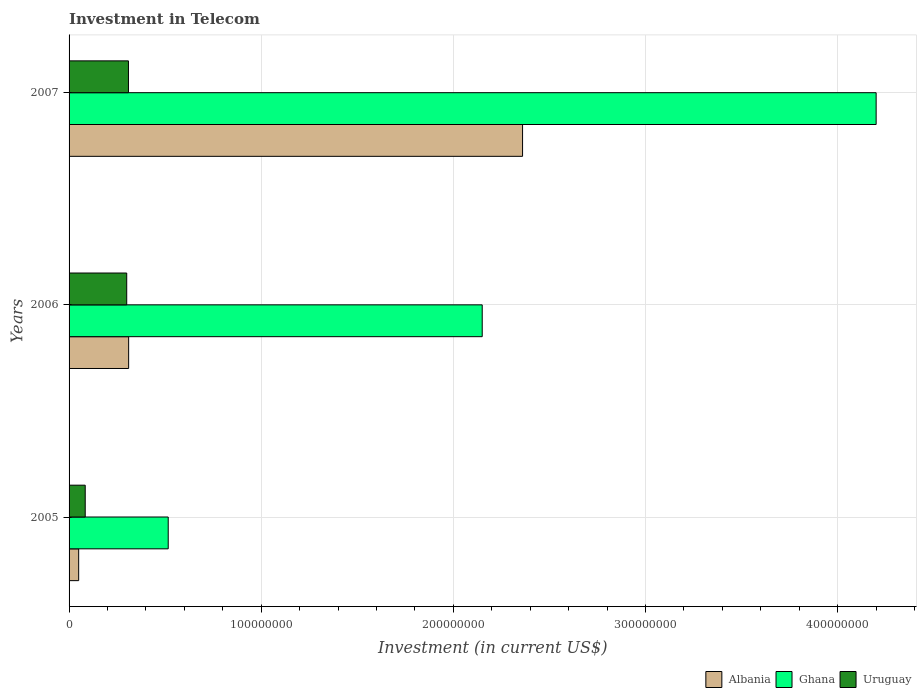Are the number of bars per tick equal to the number of legend labels?
Provide a succinct answer. Yes. In how many cases, is the number of bars for a given year not equal to the number of legend labels?
Provide a short and direct response. 0. What is the amount invested in telecom in Uruguay in 2005?
Provide a short and direct response. 8.40e+06. Across all years, what is the maximum amount invested in telecom in Albania?
Your answer should be very brief. 2.36e+08. Across all years, what is the minimum amount invested in telecom in Albania?
Your answer should be compact. 5.00e+06. What is the total amount invested in telecom in Albania in the graph?
Give a very brief answer. 2.72e+08. What is the difference between the amount invested in telecom in Ghana in 2006 and that in 2007?
Your answer should be compact. -2.05e+08. What is the difference between the amount invested in telecom in Albania in 2006 and the amount invested in telecom in Uruguay in 2005?
Provide a short and direct response. 2.26e+07. What is the average amount invested in telecom in Ghana per year?
Give a very brief answer. 2.29e+08. In the year 2006, what is the difference between the amount invested in telecom in Albania and amount invested in telecom in Ghana?
Make the answer very short. -1.84e+08. In how many years, is the amount invested in telecom in Ghana greater than 80000000 US$?
Your answer should be compact. 2. What is the ratio of the amount invested in telecom in Uruguay in 2006 to that in 2007?
Ensure brevity in your answer.  0.97. Is the amount invested in telecom in Albania in 2005 less than that in 2007?
Ensure brevity in your answer.  Yes. Is the difference between the amount invested in telecom in Albania in 2005 and 2006 greater than the difference between the amount invested in telecom in Ghana in 2005 and 2006?
Provide a succinct answer. Yes. What is the difference between the highest and the second highest amount invested in telecom in Ghana?
Give a very brief answer. 2.05e+08. What is the difference between the highest and the lowest amount invested in telecom in Ghana?
Your answer should be very brief. 3.68e+08. Is the sum of the amount invested in telecom in Ghana in 2006 and 2007 greater than the maximum amount invested in telecom in Albania across all years?
Offer a very short reply. Yes. What is the difference between two consecutive major ticks on the X-axis?
Give a very brief answer. 1.00e+08. Does the graph contain grids?
Your answer should be compact. Yes. Where does the legend appear in the graph?
Provide a succinct answer. Bottom right. How are the legend labels stacked?
Your answer should be compact. Horizontal. What is the title of the graph?
Provide a succinct answer. Investment in Telecom. Does "Papua New Guinea" appear as one of the legend labels in the graph?
Your answer should be compact. No. What is the label or title of the X-axis?
Provide a succinct answer. Investment (in current US$). What is the Investment (in current US$) of Albania in 2005?
Give a very brief answer. 5.00e+06. What is the Investment (in current US$) of Ghana in 2005?
Your response must be concise. 5.16e+07. What is the Investment (in current US$) of Uruguay in 2005?
Offer a very short reply. 8.40e+06. What is the Investment (in current US$) of Albania in 2006?
Give a very brief answer. 3.10e+07. What is the Investment (in current US$) in Ghana in 2006?
Make the answer very short. 2.15e+08. What is the Investment (in current US$) in Uruguay in 2006?
Make the answer very short. 3.00e+07. What is the Investment (in current US$) in Albania in 2007?
Provide a short and direct response. 2.36e+08. What is the Investment (in current US$) of Ghana in 2007?
Keep it short and to the point. 4.20e+08. What is the Investment (in current US$) of Uruguay in 2007?
Make the answer very short. 3.09e+07. Across all years, what is the maximum Investment (in current US$) of Albania?
Keep it short and to the point. 2.36e+08. Across all years, what is the maximum Investment (in current US$) of Ghana?
Your answer should be very brief. 4.20e+08. Across all years, what is the maximum Investment (in current US$) in Uruguay?
Your response must be concise. 3.09e+07. Across all years, what is the minimum Investment (in current US$) of Ghana?
Provide a short and direct response. 5.16e+07. Across all years, what is the minimum Investment (in current US$) of Uruguay?
Ensure brevity in your answer.  8.40e+06. What is the total Investment (in current US$) in Albania in the graph?
Your answer should be very brief. 2.72e+08. What is the total Investment (in current US$) in Ghana in the graph?
Your answer should be very brief. 6.87e+08. What is the total Investment (in current US$) of Uruguay in the graph?
Offer a terse response. 6.93e+07. What is the difference between the Investment (in current US$) of Albania in 2005 and that in 2006?
Your answer should be compact. -2.60e+07. What is the difference between the Investment (in current US$) of Ghana in 2005 and that in 2006?
Make the answer very short. -1.63e+08. What is the difference between the Investment (in current US$) in Uruguay in 2005 and that in 2006?
Provide a short and direct response. -2.16e+07. What is the difference between the Investment (in current US$) in Albania in 2005 and that in 2007?
Provide a short and direct response. -2.31e+08. What is the difference between the Investment (in current US$) of Ghana in 2005 and that in 2007?
Provide a succinct answer. -3.68e+08. What is the difference between the Investment (in current US$) in Uruguay in 2005 and that in 2007?
Offer a terse response. -2.25e+07. What is the difference between the Investment (in current US$) in Albania in 2006 and that in 2007?
Offer a terse response. -2.05e+08. What is the difference between the Investment (in current US$) of Ghana in 2006 and that in 2007?
Make the answer very short. -2.05e+08. What is the difference between the Investment (in current US$) of Uruguay in 2006 and that in 2007?
Give a very brief answer. -9.00e+05. What is the difference between the Investment (in current US$) in Albania in 2005 and the Investment (in current US$) in Ghana in 2006?
Your answer should be very brief. -2.10e+08. What is the difference between the Investment (in current US$) of Albania in 2005 and the Investment (in current US$) of Uruguay in 2006?
Ensure brevity in your answer.  -2.50e+07. What is the difference between the Investment (in current US$) in Ghana in 2005 and the Investment (in current US$) in Uruguay in 2006?
Provide a short and direct response. 2.16e+07. What is the difference between the Investment (in current US$) of Albania in 2005 and the Investment (in current US$) of Ghana in 2007?
Keep it short and to the point. -4.15e+08. What is the difference between the Investment (in current US$) of Albania in 2005 and the Investment (in current US$) of Uruguay in 2007?
Offer a terse response. -2.59e+07. What is the difference between the Investment (in current US$) of Ghana in 2005 and the Investment (in current US$) of Uruguay in 2007?
Make the answer very short. 2.07e+07. What is the difference between the Investment (in current US$) in Albania in 2006 and the Investment (in current US$) in Ghana in 2007?
Your answer should be very brief. -3.89e+08. What is the difference between the Investment (in current US$) of Ghana in 2006 and the Investment (in current US$) of Uruguay in 2007?
Provide a succinct answer. 1.84e+08. What is the average Investment (in current US$) of Albania per year?
Provide a short and direct response. 9.07e+07. What is the average Investment (in current US$) of Ghana per year?
Your response must be concise. 2.29e+08. What is the average Investment (in current US$) of Uruguay per year?
Make the answer very short. 2.31e+07. In the year 2005, what is the difference between the Investment (in current US$) in Albania and Investment (in current US$) in Ghana?
Make the answer very short. -4.66e+07. In the year 2005, what is the difference between the Investment (in current US$) of Albania and Investment (in current US$) of Uruguay?
Ensure brevity in your answer.  -3.40e+06. In the year 2005, what is the difference between the Investment (in current US$) of Ghana and Investment (in current US$) of Uruguay?
Keep it short and to the point. 4.32e+07. In the year 2006, what is the difference between the Investment (in current US$) of Albania and Investment (in current US$) of Ghana?
Provide a succinct answer. -1.84e+08. In the year 2006, what is the difference between the Investment (in current US$) in Ghana and Investment (in current US$) in Uruguay?
Offer a terse response. 1.85e+08. In the year 2007, what is the difference between the Investment (in current US$) of Albania and Investment (in current US$) of Ghana?
Your answer should be compact. -1.84e+08. In the year 2007, what is the difference between the Investment (in current US$) of Albania and Investment (in current US$) of Uruguay?
Ensure brevity in your answer.  2.05e+08. In the year 2007, what is the difference between the Investment (in current US$) of Ghana and Investment (in current US$) of Uruguay?
Offer a terse response. 3.89e+08. What is the ratio of the Investment (in current US$) of Albania in 2005 to that in 2006?
Provide a short and direct response. 0.16. What is the ratio of the Investment (in current US$) of Ghana in 2005 to that in 2006?
Provide a short and direct response. 0.24. What is the ratio of the Investment (in current US$) in Uruguay in 2005 to that in 2006?
Provide a succinct answer. 0.28. What is the ratio of the Investment (in current US$) in Albania in 2005 to that in 2007?
Your answer should be compact. 0.02. What is the ratio of the Investment (in current US$) of Ghana in 2005 to that in 2007?
Your response must be concise. 0.12. What is the ratio of the Investment (in current US$) of Uruguay in 2005 to that in 2007?
Your answer should be compact. 0.27. What is the ratio of the Investment (in current US$) in Albania in 2006 to that in 2007?
Your response must be concise. 0.13. What is the ratio of the Investment (in current US$) in Ghana in 2006 to that in 2007?
Offer a very short reply. 0.51. What is the ratio of the Investment (in current US$) in Uruguay in 2006 to that in 2007?
Offer a very short reply. 0.97. What is the difference between the highest and the second highest Investment (in current US$) in Albania?
Ensure brevity in your answer.  2.05e+08. What is the difference between the highest and the second highest Investment (in current US$) in Ghana?
Provide a short and direct response. 2.05e+08. What is the difference between the highest and the second highest Investment (in current US$) in Uruguay?
Make the answer very short. 9.00e+05. What is the difference between the highest and the lowest Investment (in current US$) in Albania?
Offer a terse response. 2.31e+08. What is the difference between the highest and the lowest Investment (in current US$) in Ghana?
Make the answer very short. 3.68e+08. What is the difference between the highest and the lowest Investment (in current US$) of Uruguay?
Your answer should be very brief. 2.25e+07. 